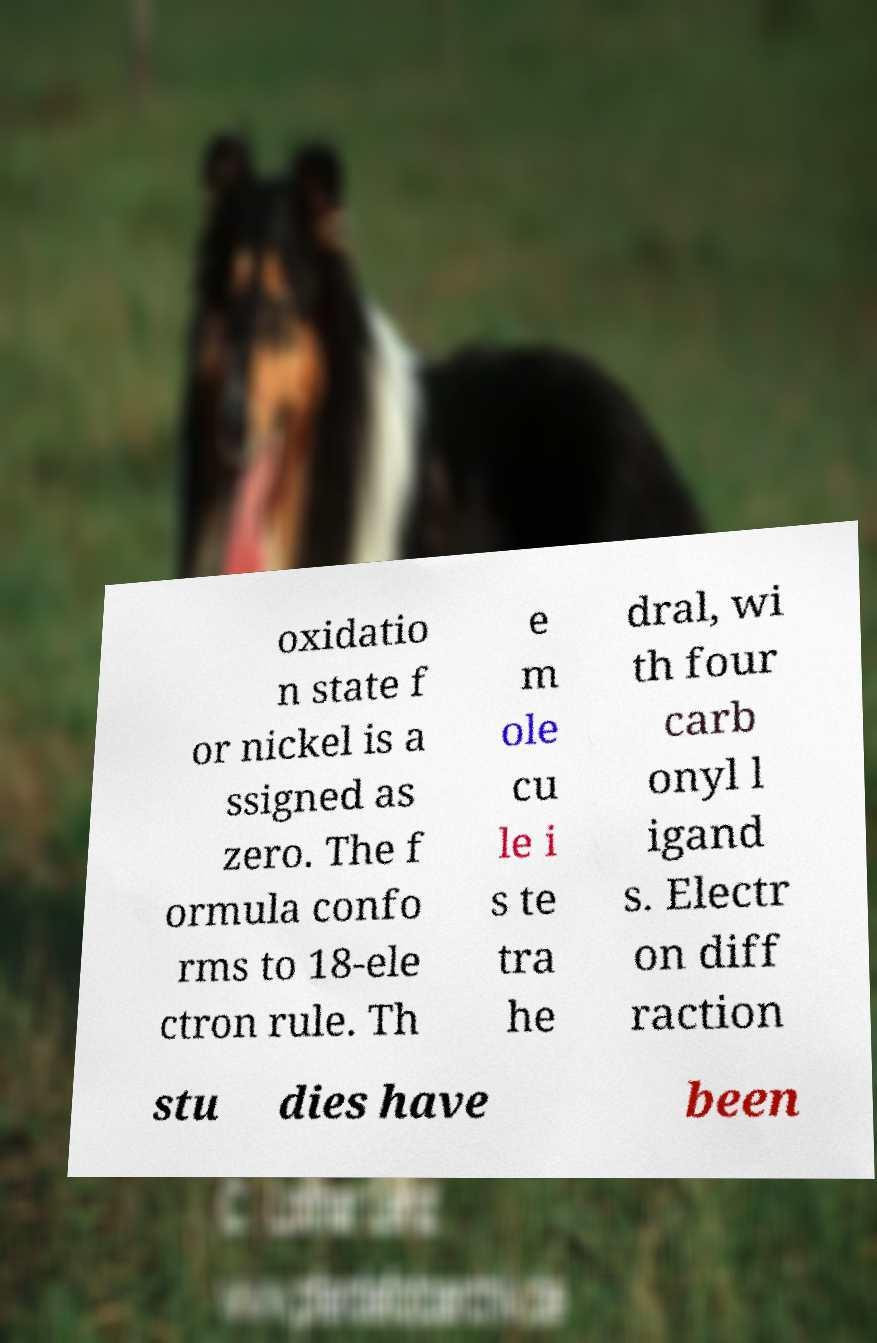Can you read and provide the text displayed in the image?This photo seems to have some interesting text. Can you extract and type it out for me? oxidatio n state f or nickel is a ssigned as zero. The f ormula confo rms to 18-ele ctron rule. Th e m ole cu le i s te tra he dral, wi th four carb onyl l igand s. Electr on diff raction stu dies have been 